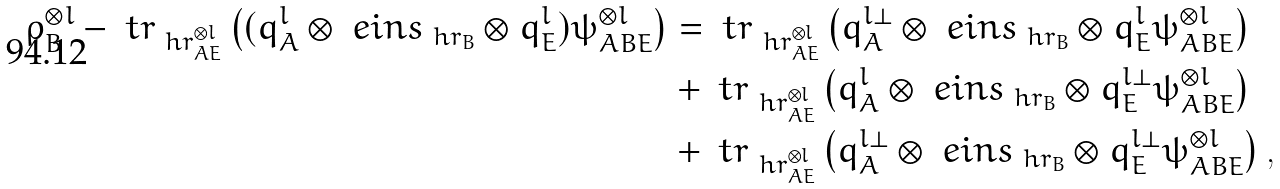Convert formula to latex. <formula><loc_0><loc_0><loc_500><loc_500>\rho _ { B } ^ { \otimes l } - \ t r _ { \ h r _ { A E } ^ { \otimes l } } \left ( ( q _ { A } ^ { l } \otimes \ e i n s _ { \ h r _ { B } } \otimes q _ { E } ^ { l } ) \psi _ { A B E } ^ { \otimes l } \right ) & = \ t r _ { \ h r _ { A E } ^ { \otimes l } } \left ( q _ { A } ^ { l \perp } \otimes \ e i n s _ { \ h r _ { B } } \otimes q _ { E } ^ { l } \psi _ { A B E } ^ { \otimes l } \right ) \\ & + \ t r _ { \ h r _ { A E } ^ { \otimes l } } \left ( q _ { A } ^ { l } \otimes \ e i n s _ { \ h r _ { B } } \otimes q _ { E } ^ { l \perp } \psi _ { A B E } ^ { \otimes l } \right ) \\ & + \ t r _ { \ h r _ { A E } ^ { \otimes l } } \left ( q _ { A } ^ { l \perp } \otimes \ e i n s _ { \ h r _ { B } } \otimes q _ { E } ^ { l \perp } \psi _ { A B E } ^ { \otimes l } \right ) ,</formula> 